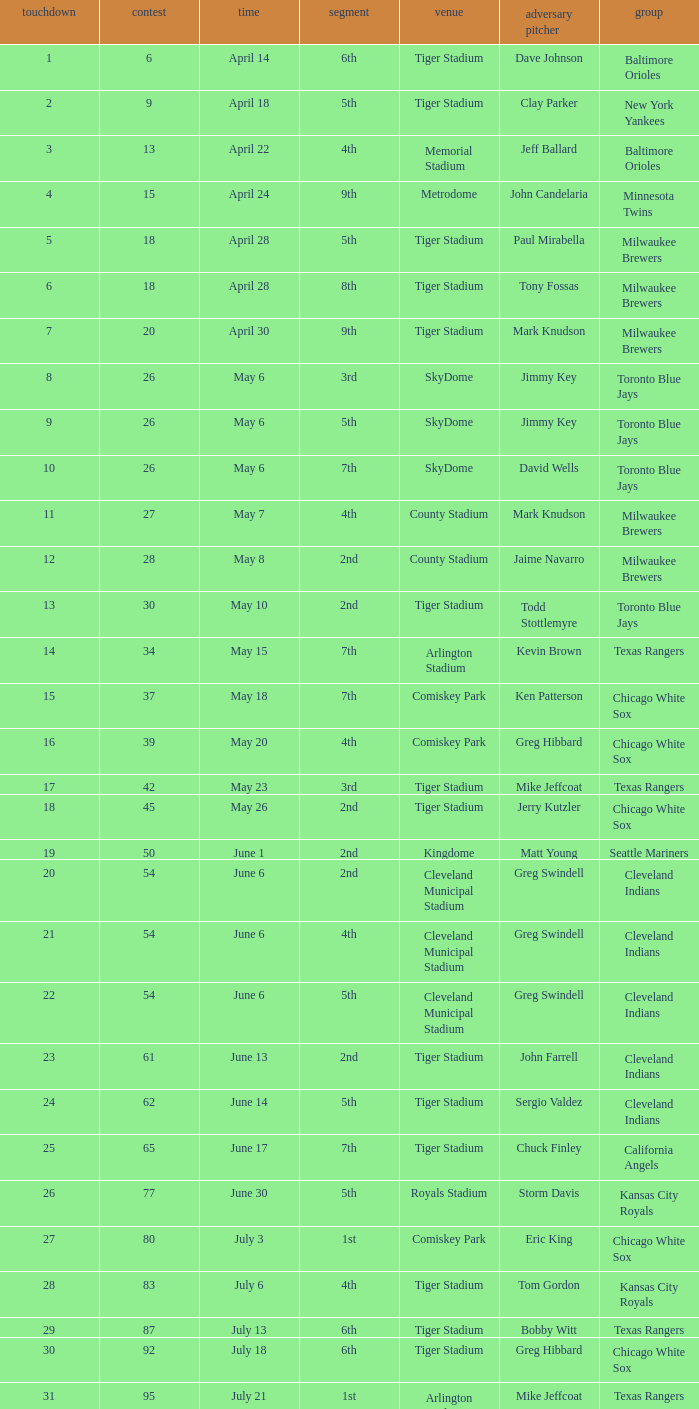On June 17 in Tiger stadium, what was the average home run? 25.0. 